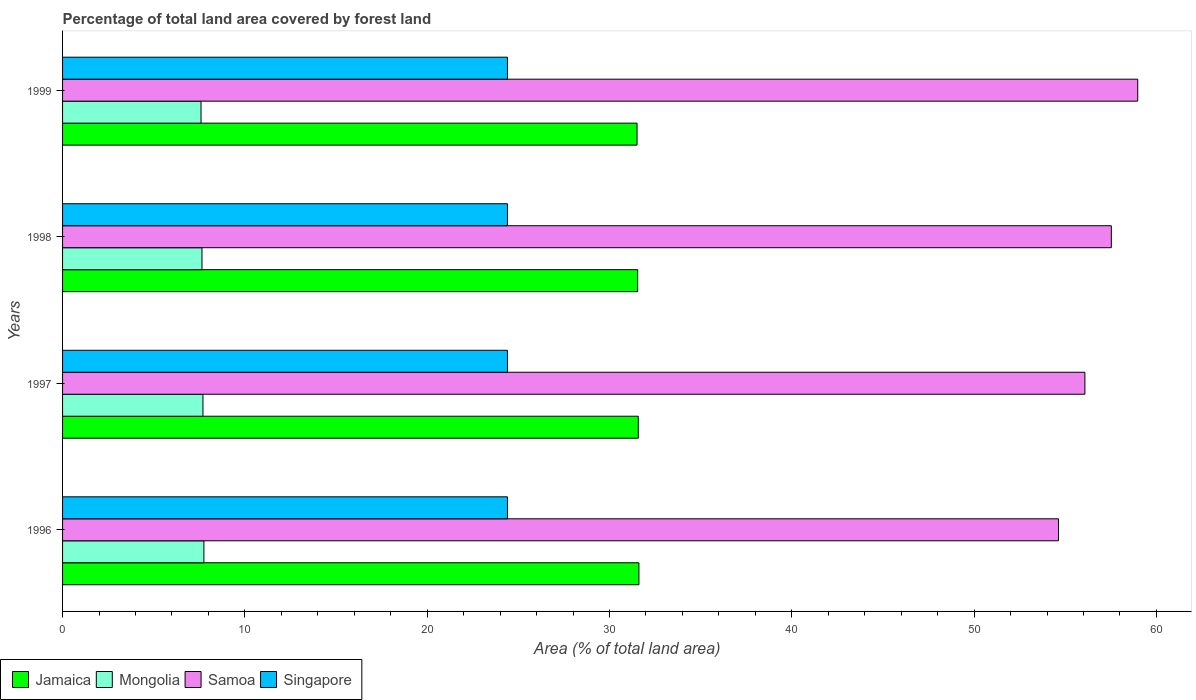How many groups of bars are there?
Give a very brief answer. 4. Are the number of bars per tick equal to the number of legend labels?
Keep it short and to the point. Yes. Are the number of bars on each tick of the Y-axis equal?
Your response must be concise. Yes. How many bars are there on the 3rd tick from the top?
Provide a short and direct response. 4. How many bars are there on the 4th tick from the bottom?
Offer a very short reply. 4. What is the percentage of forest land in Mongolia in 1999?
Keep it short and to the point. 7.59. Across all years, what is the maximum percentage of forest land in Jamaica?
Give a very brief answer. 31.61. Across all years, what is the minimum percentage of forest land in Singapore?
Your answer should be very brief. 24.4. In which year was the percentage of forest land in Jamaica maximum?
Ensure brevity in your answer.  1996. In which year was the percentage of forest land in Singapore minimum?
Ensure brevity in your answer.  1996. What is the total percentage of forest land in Mongolia in the graph?
Make the answer very short. 30.7. What is the difference between the percentage of forest land in Jamaica in 1996 and that in 1998?
Your answer should be compact. 0.07. What is the difference between the percentage of forest land in Jamaica in 1996 and the percentage of forest land in Singapore in 1999?
Keep it short and to the point. 7.21. What is the average percentage of forest land in Singapore per year?
Ensure brevity in your answer.  24.4. In the year 1998, what is the difference between the percentage of forest land in Jamaica and percentage of forest land in Singapore?
Make the answer very short. 7.14. What is the ratio of the percentage of forest land in Mongolia in 1996 to that in 1997?
Offer a terse response. 1.01. What is the difference between the highest and the second highest percentage of forest land in Jamaica?
Provide a short and direct response. 0.03. What is the difference between the highest and the lowest percentage of forest land in Singapore?
Keep it short and to the point. 0. In how many years, is the percentage of forest land in Jamaica greater than the average percentage of forest land in Jamaica taken over all years?
Offer a terse response. 2. Is it the case that in every year, the sum of the percentage of forest land in Jamaica and percentage of forest land in Mongolia is greater than the sum of percentage of forest land in Singapore and percentage of forest land in Samoa?
Offer a very short reply. No. What does the 1st bar from the top in 1997 represents?
Ensure brevity in your answer.  Singapore. What does the 2nd bar from the bottom in 1997 represents?
Provide a short and direct response. Mongolia. How many years are there in the graph?
Ensure brevity in your answer.  4. Are the values on the major ticks of X-axis written in scientific E-notation?
Make the answer very short. No. Does the graph contain any zero values?
Give a very brief answer. No. Does the graph contain grids?
Provide a succinct answer. No. How many legend labels are there?
Give a very brief answer. 4. What is the title of the graph?
Give a very brief answer. Percentage of total land area covered by forest land. Does "Burkina Faso" appear as one of the legend labels in the graph?
Give a very brief answer. No. What is the label or title of the X-axis?
Keep it short and to the point. Area (% of total land area). What is the Area (% of total land area) in Jamaica in 1996?
Offer a very short reply. 31.61. What is the Area (% of total land area) in Mongolia in 1996?
Your answer should be compact. 7.75. What is the Area (% of total land area) of Samoa in 1996?
Your answer should be compact. 54.63. What is the Area (% of total land area) in Singapore in 1996?
Provide a short and direct response. 24.4. What is the Area (% of total land area) in Jamaica in 1997?
Your answer should be compact. 31.58. What is the Area (% of total land area) of Mongolia in 1997?
Your answer should be very brief. 7.7. What is the Area (% of total land area) of Samoa in 1997?
Provide a short and direct response. 56.08. What is the Area (% of total land area) of Singapore in 1997?
Your response must be concise. 24.4. What is the Area (% of total land area) in Jamaica in 1998?
Keep it short and to the point. 31.55. What is the Area (% of total land area) in Mongolia in 1998?
Your answer should be compact. 7.65. What is the Area (% of total land area) in Samoa in 1998?
Keep it short and to the point. 57.53. What is the Area (% of total land area) in Singapore in 1998?
Your answer should be compact. 24.4. What is the Area (% of total land area) of Jamaica in 1999?
Make the answer very short. 31.51. What is the Area (% of total land area) of Mongolia in 1999?
Your answer should be compact. 7.59. What is the Area (% of total land area) in Samoa in 1999?
Provide a succinct answer. 58.98. What is the Area (% of total land area) of Singapore in 1999?
Provide a succinct answer. 24.4. Across all years, what is the maximum Area (% of total land area) of Jamaica?
Provide a short and direct response. 31.61. Across all years, what is the maximum Area (% of total land area) of Mongolia?
Give a very brief answer. 7.75. Across all years, what is the maximum Area (% of total land area) of Samoa?
Provide a succinct answer. 58.98. Across all years, what is the maximum Area (% of total land area) of Singapore?
Keep it short and to the point. 24.4. Across all years, what is the minimum Area (% of total land area) of Jamaica?
Make the answer very short. 31.51. Across all years, what is the minimum Area (% of total land area) of Mongolia?
Ensure brevity in your answer.  7.59. Across all years, what is the minimum Area (% of total land area) of Samoa?
Your answer should be very brief. 54.63. Across all years, what is the minimum Area (% of total land area) of Singapore?
Keep it short and to the point. 24.4. What is the total Area (% of total land area) in Jamaica in the graph?
Your response must be concise. 126.25. What is the total Area (% of total land area) in Mongolia in the graph?
Provide a short and direct response. 30.7. What is the total Area (% of total land area) in Samoa in the graph?
Provide a succinct answer. 227.21. What is the total Area (% of total land area) of Singapore in the graph?
Your answer should be very brief. 97.61. What is the difference between the Area (% of total land area) in Jamaica in 1996 and that in 1997?
Your response must be concise. 0.03. What is the difference between the Area (% of total land area) of Mongolia in 1996 and that in 1997?
Your answer should be compact. 0.05. What is the difference between the Area (% of total land area) of Samoa in 1996 and that in 1997?
Provide a succinct answer. -1.45. What is the difference between the Area (% of total land area) in Singapore in 1996 and that in 1997?
Your answer should be very brief. 0. What is the difference between the Area (% of total land area) in Jamaica in 1996 and that in 1998?
Provide a succinct answer. 0.07. What is the difference between the Area (% of total land area) of Mongolia in 1996 and that in 1998?
Provide a short and direct response. 0.11. What is the difference between the Area (% of total land area) in Samoa in 1996 and that in 1998?
Keep it short and to the point. -2.9. What is the difference between the Area (% of total land area) of Singapore in 1996 and that in 1998?
Give a very brief answer. 0. What is the difference between the Area (% of total land area) of Jamaica in 1996 and that in 1999?
Your answer should be compact. 0.1. What is the difference between the Area (% of total land area) in Mongolia in 1996 and that in 1999?
Your answer should be compact. 0.16. What is the difference between the Area (% of total land area) of Samoa in 1996 and that in 1999?
Offer a very short reply. -4.35. What is the difference between the Area (% of total land area) in Jamaica in 1997 and that in 1998?
Give a very brief answer. 0.03. What is the difference between the Area (% of total land area) of Mongolia in 1997 and that in 1998?
Offer a very short reply. 0.05. What is the difference between the Area (% of total land area) of Samoa in 1997 and that in 1998?
Offer a terse response. -1.45. What is the difference between the Area (% of total land area) of Singapore in 1997 and that in 1998?
Keep it short and to the point. 0. What is the difference between the Area (% of total land area) in Jamaica in 1997 and that in 1999?
Make the answer very short. 0.07. What is the difference between the Area (% of total land area) in Mongolia in 1997 and that in 1999?
Provide a short and direct response. 0.11. What is the difference between the Area (% of total land area) of Samoa in 1997 and that in 1999?
Your response must be concise. -2.9. What is the difference between the Area (% of total land area) of Singapore in 1997 and that in 1999?
Your answer should be compact. 0. What is the difference between the Area (% of total land area) of Jamaica in 1998 and that in 1999?
Make the answer very short. 0.03. What is the difference between the Area (% of total land area) of Mongolia in 1998 and that in 1999?
Your answer should be very brief. 0.05. What is the difference between the Area (% of total land area) in Samoa in 1998 and that in 1999?
Your answer should be compact. -1.45. What is the difference between the Area (% of total land area) in Singapore in 1998 and that in 1999?
Keep it short and to the point. 0. What is the difference between the Area (% of total land area) of Jamaica in 1996 and the Area (% of total land area) of Mongolia in 1997?
Keep it short and to the point. 23.91. What is the difference between the Area (% of total land area) of Jamaica in 1996 and the Area (% of total land area) of Samoa in 1997?
Your answer should be very brief. -24.46. What is the difference between the Area (% of total land area) of Jamaica in 1996 and the Area (% of total land area) of Singapore in 1997?
Offer a terse response. 7.21. What is the difference between the Area (% of total land area) of Mongolia in 1996 and the Area (% of total land area) of Samoa in 1997?
Offer a terse response. -48.32. What is the difference between the Area (% of total land area) in Mongolia in 1996 and the Area (% of total land area) in Singapore in 1997?
Keep it short and to the point. -16.65. What is the difference between the Area (% of total land area) in Samoa in 1996 and the Area (% of total land area) in Singapore in 1997?
Your response must be concise. 30.23. What is the difference between the Area (% of total land area) of Jamaica in 1996 and the Area (% of total land area) of Mongolia in 1998?
Give a very brief answer. 23.97. What is the difference between the Area (% of total land area) of Jamaica in 1996 and the Area (% of total land area) of Samoa in 1998?
Make the answer very short. -25.91. What is the difference between the Area (% of total land area) in Jamaica in 1996 and the Area (% of total land area) in Singapore in 1998?
Your answer should be very brief. 7.21. What is the difference between the Area (% of total land area) of Mongolia in 1996 and the Area (% of total land area) of Samoa in 1998?
Offer a very short reply. -49.77. What is the difference between the Area (% of total land area) of Mongolia in 1996 and the Area (% of total land area) of Singapore in 1998?
Offer a very short reply. -16.65. What is the difference between the Area (% of total land area) of Samoa in 1996 and the Area (% of total land area) of Singapore in 1998?
Make the answer very short. 30.23. What is the difference between the Area (% of total land area) in Jamaica in 1996 and the Area (% of total land area) in Mongolia in 1999?
Provide a short and direct response. 24.02. What is the difference between the Area (% of total land area) in Jamaica in 1996 and the Area (% of total land area) in Samoa in 1999?
Make the answer very short. -27.36. What is the difference between the Area (% of total land area) of Jamaica in 1996 and the Area (% of total land area) of Singapore in 1999?
Give a very brief answer. 7.21. What is the difference between the Area (% of total land area) in Mongolia in 1996 and the Area (% of total land area) in Samoa in 1999?
Offer a very short reply. -51.22. What is the difference between the Area (% of total land area) of Mongolia in 1996 and the Area (% of total land area) of Singapore in 1999?
Offer a terse response. -16.65. What is the difference between the Area (% of total land area) of Samoa in 1996 and the Area (% of total land area) of Singapore in 1999?
Your answer should be very brief. 30.23. What is the difference between the Area (% of total land area) of Jamaica in 1997 and the Area (% of total land area) of Mongolia in 1998?
Offer a very short reply. 23.93. What is the difference between the Area (% of total land area) in Jamaica in 1997 and the Area (% of total land area) in Samoa in 1998?
Offer a terse response. -25.95. What is the difference between the Area (% of total land area) of Jamaica in 1997 and the Area (% of total land area) of Singapore in 1998?
Offer a terse response. 7.18. What is the difference between the Area (% of total land area) of Mongolia in 1997 and the Area (% of total land area) of Samoa in 1998?
Ensure brevity in your answer.  -49.83. What is the difference between the Area (% of total land area) in Mongolia in 1997 and the Area (% of total land area) in Singapore in 1998?
Make the answer very short. -16.7. What is the difference between the Area (% of total land area) of Samoa in 1997 and the Area (% of total land area) of Singapore in 1998?
Your answer should be compact. 31.67. What is the difference between the Area (% of total land area) in Jamaica in 1997 and the Area (% of total land area) in Mongolia in 1999?
Offer a very short reply. 23.99. What is the difference between the Area (% of total land area) of Jamaica in 1997 and the Area (% of total land area) of Samoa in 1999?
Your answer should be compact. -27.4. What is the difference between the Area (% of total land area) of Jamaica in 1997 and the Area (% of total land area) of Singapore in 1999?
Make the answer very short. 7.18. What is the difference between the Area (% of total land area) in Mongolia in 1997 and the Area (% of total land area) in Samoa in 1999?
Your answer should be compact. -51.28. What is the difference between the Area (% of total land area) of Mongolia in 1997 and the Area (% of total land area) of Singapore in 1999?
Your response must be concise. -16.7. What is the difference between the Area (% of total land area) in Samoa in 1997 and the Area (% of total land area) in Singapore in 1999?
Make the answer very short. 31.67. What is the difference between the Area (% of total land area) of Jamaica in 1998 and the Area (% of total land area) of Mongolia in 1999?
Your answer should be very brief. 23.95. What is the difference between the Area (% of total land area) of Jamaica in 1998 and the Area (% of total land area) of Samoa in 1999?
Give a very brief answer. -27.43. What is the difference between the Area (% of total land area) of Jamaica in 1998 and the Area (% of total land area) of Singapore in 1999?
Keep it short and to the point. 7.14. What is the difference between the Area (% of total land area) of Mongolia in 1998 and the Area (% of total land area) of Samoa in 1999?
Your answer should be compact. -51.33. What is the difference between the Area (% of total land area) in Mongolia in 1998 and the Area (% of total land area) in Singapore in 1999?
Keep it short and to the point. -16.76. What is the difference between the Area (% of total land area) in Samoa in 1998 and the Area (% of total land area) in Singapore in 1999?
Provide a succinct answer. 33.12. What is the average Area (% of total land area) of Jamaica per year?
Give a very brief answer. 31.56. What is the average Area (% of total land area) of Mongolia per year?
Ensure brevity in your answer.  7.67. What is the average Area (% of total land area) of Samoa per year?
Provide a succinct answer. 56.8. What is the average Area (% of total land area) of Singapore per year?
Give a very brief answer. 24.4. In the year 1996, what is the difference between the Area (% of total land area) in Jamaica and Area (% of total land area) in Mongolia?
Give a very brief answer. 23.86. In the year 1996, what is the difference between the Area (% of total land area) in Jamaica and Area (% of total land area) in Samoa?
Your answer should be compact. -23.01. In the year 1996, what is the difference between the Area (% of total land area) in Jamaica and Area (% of total land area) in Singapore?
Provide a succinct answer. 7.21. In the year 1996, what is the difference between the Area (% of total land area) in Mongolia and Area (% of total land area) in Samoa?
Give a very brief answer. -46.88. In the year 1996, what is the difference between the Area (% of total land area) in Mongolia and Area (% of total land area) in Singapore?
Your answer should be compact. -16.65. In the year 1996, what is the difference between the Area (% of total land area) of Samoa and Area (% of total land area) of Singapore?
Your answer should be very brief. 30.23. In the year 1997, what is the difference between the Area (% of total land area) of Jamaica and Area (% of total land area) of Mongolia?
Provide a short and direct response. 23.88. In the year 1997, what is the difference between the Area (% of total land area) of Jamaica and Area (% of total land area) of Samoa?
Your answer should be compact. -24.5. In the year 1997, what is the difference between the Area (% of total land area) of Jamaica and Area (% of total land area) of Singapore?
Offer a terse response. 7.18. In the year 1997, what is the difference between the Area (% of total land area) of Mongolia and Area (% of total land area) of Samoa?
Offer a terse response. -48.38. In the year 1997, what is the difference between the Area (% of total land area) in Mongolia and Area (% of total land area) in Singapore?
Your answer should be very brief. -16.7. In the year 1997, what is the difference between the Area (% of total land area) in Samoa and Area (% of total land area) in Singapore?
Your answer should be compact. 31.67. In the year 1998, what is the difference between the Area (% of total land area) of Jamaica and Area (% of total land area) of Mongolia?
Offer a very short reply. 23.9. In the year 1998, what is the difference between the Area (% of total land area) of Jamaica and Area (% of total land area) of Samoa?
Keep it short and to the point. -25.98. In the year 1998, what is the difference between the Area (% of total land area) in Jamaica and Area (% of total land area) in Singapore?
Your answer should be very brief. 7.14. In the year 1998, what is the difference between the Area (% of total land area) of Mongolia and Area (% of total land area) of Samoa?
Provide a succinct answer. -49.88. In the year 1998, what is the difference between the Area (% of total land area) in Mongolia and Area (% of total land area) in Singapore?
Your answer should be compact. -16.76. In the year 1998, what is the difference between the Area (% of total land area) in Samoa and Area (% of total land area) in Singapore?
Provide a short and direct response. 33.12. In the year 1999, what is the difference between the Area (% of total land area) in Jamaica and Area (% of total land area) in Mongolia?
Give a very brief answer. 23.92. In the year 1999, what is the difference between the Area (% of total land area) of Jamaica and Area (% of total land area) of Samoa?
Offer a very short reply. -27.46. In the year 1999, what is the difference between the Area (% of total land area) of Jamaica and Area (% of total land area) of Singapore?
Provide a short and direct response. 7.11. In the year 1999, what is the difference between the Area (% of total land area) of Mongolia and Area (% of total land area) of Samoa?
Your answer should be very brief. -51.38. In the year 1999, what is the difference between the Area (% of total land area) in Mongolia and Area (% of total land area) in Singapore?
Ensure brevity in your answer.  -16.81. In the year 1999, what is the difference between the Area (% of total land area) of Samoa and Area (% of total land area) of Singapore?
Your answer should be very brief. 34.57. What is the ratio of the Area (% of total land area) of Mongolia in 1996 to that in 1997?
Offer a very short reply. 1.01. What is the ratio of the Area (% of total land area) of Samoa in 1996 to that in 1997?
Keep it short and to the point. 0.97. What is the ratio of the Area (% of total land area) of Jamaica in 1996 to that in 1998?
Ensure brevity in your answer.  1. What is the ratio of the Area (% of total land area) of Mongolia in 1996 to that in 1998?
Provide a succinct answer. 1.01. What is the ratio of the Area (% of total land area) of Samoa in 1996 to that in 1998?
Your answer should be compact. 0.95. What is the ratio of the Area (% of total land area) of Mongolia in 1996 to that in 1999?
Offer a terse response. 1.02. What is the ratio of the Area (% of total land area) in Samoa in 1996 to that in 1999?
Your answer should be very brief. 0.93. What is the ratio of the Area (% of total land area) of Samoa in 1997 to that in 1998?
Your response must be concise. 0.97. What is the ratio of the Area (% of total land area) of Jamaica in 1997 to that in 1999?
Ensure brevity in your answer.  1. What is the ratio of the Area (% of total land area) of Mongolia in 1997 to that in 1999?
Keep it short and to the point. 1.01. What is the ratio of the Area (% of total land area) of Samoa in 1997 to that in 1999?
Your answer should be very brief. 0.95. What is the ratio of the Area (% of total land area) in Jamaica in 1998 to that in 1999?
Ensure brevity in your answer.  1. What is the ratio of the Area (% of total land area) of Mongolia in 1998 to that in 1999?
Provide a succinct answer. 1.01. What is the ratio of the Area (% of total land area) in Samoa in 1998 to that in 1999?
Ensure brevity in your answer.  0.98. What is the ratio of the Area (% of total land area) in Singapore in 1998 to that in 1999?
Your response must be concise. 1. What is the difference between the highest and the second highest Area (% of total land area) of Jamaica?
Ensure brevity in your answer.  0.03. What is the difference between the highest and the second highest Area (% of total land area) of Mongolia?
Offer a terse response. 0.05. What is the difference between the highest and the second highest Area (% of total land area) in Samoa?
Keep it short and to the point. 1.45. What is the difference between the highest and the lowest Area (% of total land area) of Jamaica?
Provide a succinct answer. 0.1. What is the difference between the highest and the lowest Area (% of total land area) in Mongolia?
Your answer should be compact. 0.16. What is the difference between the highest and the lowest Area (% of total land area) in Samoa?
Your response must be concise. 4.35. What is the difference between the highest and the lowest Area (% of total land area) in Singapore?
Your answer should be compact. 0. 